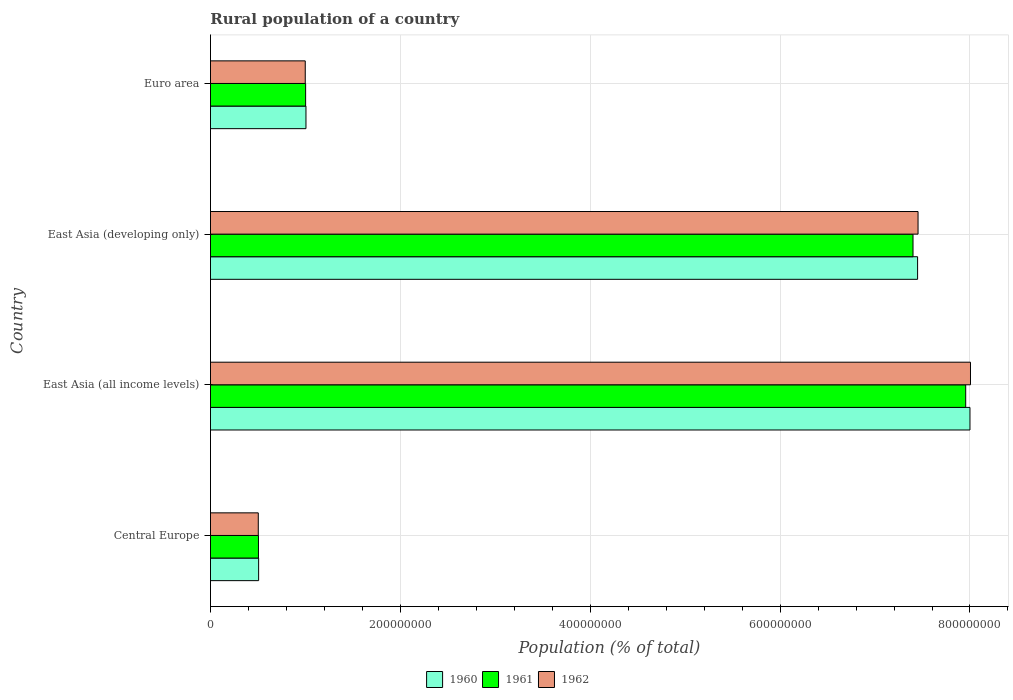How many groups of bars are there?
Provide a succinct answer. 4. How many bars are there on the 3rd tick from the top?
Your answer should be compact. 3. What is the label of the 3rd group of bars from the top?
Keep it short and to the point. East Asia (all income levels). What is the rural population in 1962 in East Asia (developing only)?
Your answer should be very brief. 7.45e+08. Across all countries, what is the maximum rural population in 1960?
Your answer should be compact. 8.00e+08. Across all countries, what is the minimum rural population in 1962?
Your answer should be compact. 5.04e+07. In which country was the rural population in 1961 maximum?
Your answer should be very brief. East Asia (all income levels). In which country was the rural population in 1962 minimum?
Your answer should be compact. Central Europe. What is the total rural population in 1962 in the graph?
Keep it short and to the point. 1.70e+09. What is the difference between the rural population in 1961 in Central Europe and that in East Asia (developing only)?
Give a very brief answer. -6.89e+08. What is the difference between the rural population in 1962 in Euro area and the rural population in 1960 in East Asia (developing only)?
Offer a terse response. -6.45e+08. What is the average rural population in 1962 per country?
Give a very brief answer. 4.24e+08. What is the difference between the rural population in 1960 and rural population in 1961 in Central Europe?
Give a very brief answer. 1.81e+05. In how many countries, is the rural population in 1962 greater than 280000000 %?
Ensure brevity in your answer.  2. What is the ratio of the rural population in 1960 in Central Europe to that in Euro area?
Provide a succinct answer. 0.5. Is the rural population in 1961 in Central Europe less than that in East Asia (all income levels)?
Give a very brief answer. Yes. What is the difference between the highest and the second highest rural population in 1960?
Make the answer very short. 5.52e+07. What is the difference between the highest and the lowest rural population in 1960?
Offer a terse response. 7.49e+08. In how many countries, is the rural population in 1960 greater than the average rural population in 1960 taken over all countries?
Your answer should be very brief. 2. Is the sum of the rural population in 1960 in East Asia (all income levels) and East Asia (developing only) greater than the maximum rural population in 1962 across all countries?
Ensure brevity in your answer.  Yes. What does the 1st bar from the top in East Asia (developing only) represents?
Provide a succinct answer. 1962. What does the 1st bar from the bottom in Central Europe represents?
Your answer should be very brief. 1960. Is it the case that in every country, the sum of the rural population in 1961 and rural population in 1962 is greater than the rural population in 1960?
Offer a terse response. Yes. How many bars are there?
Make the answer very short. 12. Are all the bars in the graph horizontal?
Your answer should be compact. Yes. Are the values on the major ticks of X-axis written in scientific E-notation?
Keep it short and to the point. No. Does the graph contain any zero values?
Give a very brief answer. No. What is the title of the graph?
Offer a very short reply. Rural population of a country. What is the label or title of the X-axis?
Offer a very short reply. Population (% of total). What is the label or title of the Y-axis?
Your response must be concise. Country. What is the Population (% of total) in 1960 in Central Europe?
Your answer should be very brief. 5.07e+07. What is the Population (% of total) in 1961 in Central Europe?
Provide a short and direct response. 5.05e+07. What is the Population (% of total) in 1962 in Central Europe?
Provide a succinct answer. 5.04e+07. What is the Population (% of total) of 1960 in East Asia (all income levels)?
Your answer should be compact. 8.00e+08. What is the Population (% of total) in 1961 in East Asia (all income levels)?
Provide a short and direct response. 7.96e+08. What is the Population (% of total) of 1962 in East Asia (all income levels)?
Your response must be concise. 8.01e+08. What is the Population (% of total) in 1960 in East Asia (developing only)?
Provide a short and direct response. 7.45e+08. What is the Population (% of total) in 1961 in East Asia (developing only)?
Provide a short and direct response. 7.40e+08. What is the Population (% of total) in 1962 in East Asia (developing only)?
Your answer should be compact. 7.45e+08. What is the Population (% of total) in 1960 in Euro area?
Your answer should be very brief. 1.01e+08. What is the Population (% of total) of 1961 in Euro area?
Provide a succinct answer. 1.00e+08. What is the Population (% of total) of 1962 in Euro area?
Your answer should be very brief. 9.98e+07. Across all countries, what is the maximum Population (% of total) in 1960?
Provide a succinct answer. 8.00e+08. Across all countries, what is the maximum Population (% of total) of 1961?
Give a very brief answer. 7.96e+08. Across all countries, what is the maximum Population (% of total) in 1962?
Ensure brevity in your answer.  8.01e+08. Across all countries, what is the minimum Population (% of total) of 1960?
Offer a terse response. 5.07e+07. Across all countries, what is the minimum Population (% of total) in 1961?
Ensure brevity in your answer.  5.05e+07. Across all countries, what is the minimum Population (% of total) in 1962?
Keep it short and to the point. 5.04e+07. What is the total Population (% of total) of 1960 in the graph?
Provide a succinct answer. 1.70e+09. What is the total Population (% of total) of 1961 in the graph?
Offer a very short reply. 1.69e+09. What is the total Population (% of total) in 1962 in the graph?
Ensure brevity in your answer.  1.70e+09. What is the difference between the Population (% of total) in 1960 in Central Europe and that in East Asia (all income levels)?
Make the answer very short. -7.49e+08. What is the difference between the Population (% of total) of 1961 in Central Europe and that in East Asia (all income levels)?
Provide a succinct answer. -7.45e+08. What is the difference between the Population (% of total) of 1962 in Central Europe and that in East Asia (all income levels)?
Ensure brevity in your answer.  -7.50e+08. What is the difference between the Population (% of total) of 1960 in Central Europe and that in East Asia (developing only)?
Ensure brevity in your answer.  -6.94e+08. What is the difference between the Population (% of total) of 1961 in Central Europe and that in East Asia (developing only)?
Provide a succinct answer. -6.89e+08. What is the difference between the Population (% of total) of 1962 in Central Europe and that in East Asia (developing only)?
Your answer should be very brief. -6.95e+08. What is the difference between the Population (% of total) of 1960 in Central Europe and that in Euro area?
Your answer should be compact. -4.99e+07. What is the difference between the Population (% of total) of 1961 in Central Europe and that in Euro area?
Give a very brief answer. -4.97e+07. What is the difference between the Population (% of total) in 1962 in Central Europe and that in Euro area?
Provide a short and direct response. -4.95e+07. What is the difference between the Population (% of total) in 1960 in East Asia (all income levels) and that in East Asia (developing only)?
Ensure brevity in your answer.  5.52e+07. What is the difference between the Population (% of total) of 1961 in East Asia (all income levels) and that in East Asia (developing only)?
Provide a succinct answer. 5.55e+07. What is the difference between the Population (% of total) of 1962 in East Asia (all income levels) and that in East Asia (developing only)?
Offer a terse response. 5.52e+07. What is the difference between the Population (% of total) in 1960 in East Asia (all income levels) and that in Euro area?
Ensure brevity in your answer.  6.99e+08. What is the difference between the Population (% of total) of 1961 in East Asia (all income levels) and that in Euro area?
Give a very brief answer. 6.95e+08. What is the difference between the Population (% of total) of 1962 in East Asia (all income levels) and that in Euro area?
Provide a short and direct response. 7.01e+08. What is the difference between the Population (% of total) of 1960 in East Asia (developing only) and that in Euro area?
Offer a very short reply. 6.44e+08. What is the difference between the Population (% of total) in 1961 in East Asia (developing only) and that in Euro area?
Keep it short and to the point. 6.40e+08. What is the difference between the Population (% of total) in 1962 in East Asia (developing only) and that in Euro area?
Offer a terse response. 6.45e+08. What is the difference between the Population (% of total) in 1960 in Central Europe and the Population (% of total) in 1961 in East Asia (all income levels)?
Ensure brevity in your answer.  -7.45e+08. What is the difference between the Population (% of total) in 1960 in Central Europe and the Population (% of total) in 1962 in East Asia (all income levels)?
Offer a terse response. -7.50e+08. What is the difference between the Population (% of total) in 1961 in Central Europe and the Population (% of total) in 1962 in East Asia (all income levels)?
Your response must be concise. -7.50e+08. What is the difference between the Population (% of total) in 1960 in Central Europe and the Population (% of total) in 1961 in East Asia (developing only)?
Provide a succinct answer. -6.89e+08. What is the difference between the Population (% of total) of 1960 in Central Europe and the Population (% of total) of 1962 in East Asia (developing only)?
Provide a succinct answer. -6.95e+08. What is the difference between the Population (% of total) in 1961 in Central Europe and the Population (% of total) in 1962 in East Asia (developing only)?
Offer a terse response. -6.95e+08. What is the difference between the Population (% of total) in 1960 in Central Europe and the Population (% of total) in 1961 in Euro area?
Provide a short and direct response. -4.95e+07. What is the difference between the Population (% of total) of 1960 in Central Europe and the Population (% of total) of 1962 in Euro area?
Offer a very short reply. -4.91e+07. What is the difference between the Population (% of total) in 1961 in Central Europe and the Population (% of total) in 1962 in Euro area?
Offer a very short reply. -4.93e+07. What is the difference between the Population (% of total) of 1960 in East Asia (all income levels) and the Population (% of total) of 1961 in East Asia (developing only)?
Your answer should be very brief. 6.00e+07. What is the difference between the Population (% of total) of 1960 in East Asia (all income levels) and the Population (% of total) of 1962 in East Asia (developing only)?
Your answer should be compact. 5.47e+07. What is the difference between the Population (% of total) in 1961 in East Asia (all income levels) and the Population (% of total) in 1962 in East Asia (developing only)?
Your answer should be very brief. 5.02e+07. What is the difference between the Population (% of total) in 1960 in East Asia (all income levels) and the Population (% of total) in 1961 in Euro area?
Give a very brief answer. 7.00e+08. What is the difference between the Population (% of total) in 1960 in East Asia (all income levels) and the Population (% of total) in 1962 in Euro area?
Provide a short and direct response. 7.00e+08. What is the difference between the Population (% of total) of 1961 in East Asia (all income levels) and the Population (% of total) of 1962 in Euro area?
Offer a very short reply. 6.96e+08. What is the difference between the Population (% of total) in 1960 in East Asia (developing only) and the Population (% of total) in 1961 in Euro area?
Offer a very short reply. 6.45e+08. What is the difference between the Population (% of total) of 1960 in East Asia (developing only) and the Population (% of total) of 1962 in Euro area?
Offer a terse response. 6.45e+08. What is the difference between the Population (% of total) of 1961 in East Asia (developing only) and the Population (% of total) of 1962 in Euro area?
Offer a very short reply. 6.40e+08. What is the average Population (% of total) in 1960 per country?
Provide a short and direct response. 4.24e+08. What is the average Population (% of total) in 1961 per country?
Your response must be concise. 4.22e+08. What is the average Population (% of total) in 1962 per country?
Provide a short and direct response. 4.24e+08. What is the difference between the Population (% of total) of 1960 and Population (% of total) of 1961 in Central Europe?
Provide a succinct answer. 1.81e+05. What is the difference between the Population (% of total) of 1960 and Population (% of total) of 1962 in Central Europe?
Ensure brevity in your answer.  3.68e+05. What is the difference between the Population (% of total) in 1961 and Population (% of total) in 1962 in Central Europe?
Offer a very short reply. 1.88e+05. What is the difference between the Population (% of total) of 1960 and Population (% of total) of 1961 in East Asia (all income levels)?
Offer a terse response. 4.49e+06. What is the difference between the Population (% of total) of 1960 and Population (% of total) of 1962 in East Asia (all income levels)?
Your response must be concise. -5.54e+05. What is the difference between the Population (% of total) of 1961 and Population (% of total) of 1962 in East Asia (all income levels)?
Your answer should be compact. -5.04e+06. What is the difference between the Population (% of total) of 1960 and Population (% of total) of 1961 in East Asia (developing only)?
Give a very brief answer. 4.83e+06. What is the difference between the Population (% of total) in 1960 and Population (% of total) in 1962 in East Asia (developing only)?
Make the answer very short. -4.83e+05. What is the difference between the Population (% of total) of 1961 and Population (% of total) of 1962 in East Asia (developing only)?
Provide a short and direct response. -5.31e+06. What is the difference between the Population (% of total) of 1960 and Population (% of total) of 1961 in Euro area?
Offer a terse response. 3.61e+05. What is the difference between the Population (% of total) in 1960 and Population (% of total) in 1962 in Euro area?
Keep it short and to the point. 7.59e+05. What is the difference between the Population (% of total) in 1961 and Population (% of total) in 1962 in Euro area?
Offer a terse response. 3.98e+05. What is the ratio of the Population (% of total) in 1960 in Central Europe to that in East Asia (all income levels)?
Your answer should be compact. 0.06. What is the ratio of the Population (% of total) of 1961 in Central Europe to that in East Asia (all income levels)?
Give a very brief answer. 0.06. What is the ratio of the Population (% of total) in 1962 in Central Europe to that in East Asia (all income levels)?
Provide a short and direct response. 0.06. What is the ratio of the Population (% of total) in 1960 in Central Europe to that in East Asia (developing only)?
Provide a succinct answer. 0.07. What is the ratio of the Population (% of total) in 1961 in Central Europe to that in East Asia (developing only)?
Offer a very short reply. 0.07. What is the ratio of the Population (% of total) in 1962 in Central Europe to that in East Asia (developing only)?
Give a very brief answer. 0.07. What is the ratio of the Population (% of total) of 1960 in Central Europe to that in Euro area?
Offer a terse response. 0.5. What is the ratio of the Population (% of total) of 1961 in Central Europe to that in Euro area?
Your answer should be very brief. 0.5. What is the ratio of the Population (% of total) of 1962 in Central Europe to that in Euro area?
Ensure brevity in your answer.  0.5. What is the ratio of the Population (% of total) of 1960 in East Asia (all income levels) to that in East Asia (developing only)?
Provide a short and direct response. 1.07. What is the ratio of the Population (% of total) of 1961 in East Asia (all income levels) to that in East Asia (developing only)?
Give a very brief answer. 1.07. What is the ratio of the Population (% of total) of 1962 in East Asia (all income levels) to that in East Asia (developing only)?
Your answer should be compact. 1.07. What is the ratio of the Population (% of total) in 1960 in East Asia (all income levels) to that in Euro area?
Provide a succinct answer. 7.95. What is the ratio of the Population (% of total) in 1961 in East Asia (all income levels) to that in Euro area?
Your answer should be very brief. 7.94. What is the ratio of the Population (% of total) of 1962 in East Asia (all income levels) to that in Euro area?
Provide a short and direct response. 8.02. What is the ratio of the Population (% of total) of 1960 in East Asia (developing only) to that in Euro area?
Provide a short and direct response. 7.4. What is the ratio of the Population (% of total) of 1961 in East Asia (developing only) to that in Euro area?
Provide a succinct answer. 7.38. What is the ratio of the Population (% of total) in 1962 in East Asia (developing only) to that in Euro area?
Your answer should be very brief. 7.47. What is the difference between the highest and the second highest Population (% of total) in 1960?
Ensure brevity in your answer.  5.52e+07. What is the difference between the highest and the second highest Population (% of total) in 1961?
Give a very brief answer. 5.55e+07. What is the difference between the highest and the second highest Population (% of total) of 1962?
Your response must be concise. 5.52e+07. What is the difference between the highest and the lowest Population (% of total) in 1960?
Offer a terse response. 7.49e+08. What is the difference between the highest and the lowest Population (% of total) in 1961?
Make the answer very short. 7.45e+08. What is the difference between the highest and the lowest Population (% of total) in 1962?
Your answer should be very brief. 7.50e+08. 